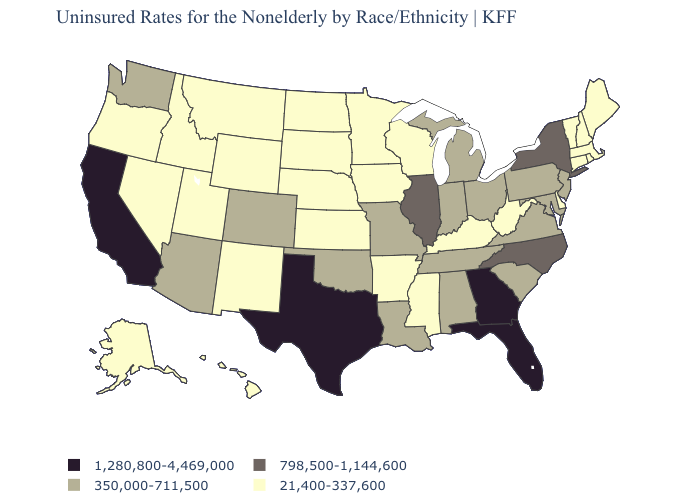Does Colorado have the lowest value in the West?
Answer briefly. No. Name the states that have a value in the range 350,000-711,500?
Be succinct. Alabama, Arizona, Colorado, Indiana, Louisiana, Maryland, Michigan, Missouri, New Jersey, Ohio, Oklahoma, Pennsylvania, South Carolina, Tennessee, Virginia, Washington. Which states have the highest value in the USA?
Give a very brief answer. California, Florida, Georgia, Texas. Does Hawaii have the lowest value in the USA?
Concise answer only. Yes. Name the states that have a value in the range 798,500-1,144,600?
Give a very brief answer. Illinois, New York, North Carolina. Does the map have missing data?
Concise answer only. No. Among the states that border Kentucky , which have the highest value?
Concise answer only. Illinois. Which states have the lowest value in the MidWest?
Be succinct. Iowa, Kansas, Minnesota, Nebraska, North Dakota, South Dakota, Wisconsin. Which states hav the highest value in the West?
Keep it brief. California. Which states have the highest value in the USA?
Short answer required. California, Florida, Georgia, Texas. What is the lowest value in states that border Georgia?
Concise answer only. 350,000-711,500. What is the highest value in states that border Maine?
Short answer required. 21,400-337,600. Name the states that have a value in the range 350,000-711,500?
Write a very short answer. Alabama, Arizona, Colorado, Indiana, Louisiana, Maryland, Michigan, Missouri, New Jersey, Ohio, Oklahoma, Pennsylvania, South Carolina, Tennessee, Virginia, Washington. What is the highest value in the MidWest ?
Write a very short answer. 798,500-1,144,600. What is the highest value in the West ?
Write a very short answer. 1,280,800-4,469,000. 